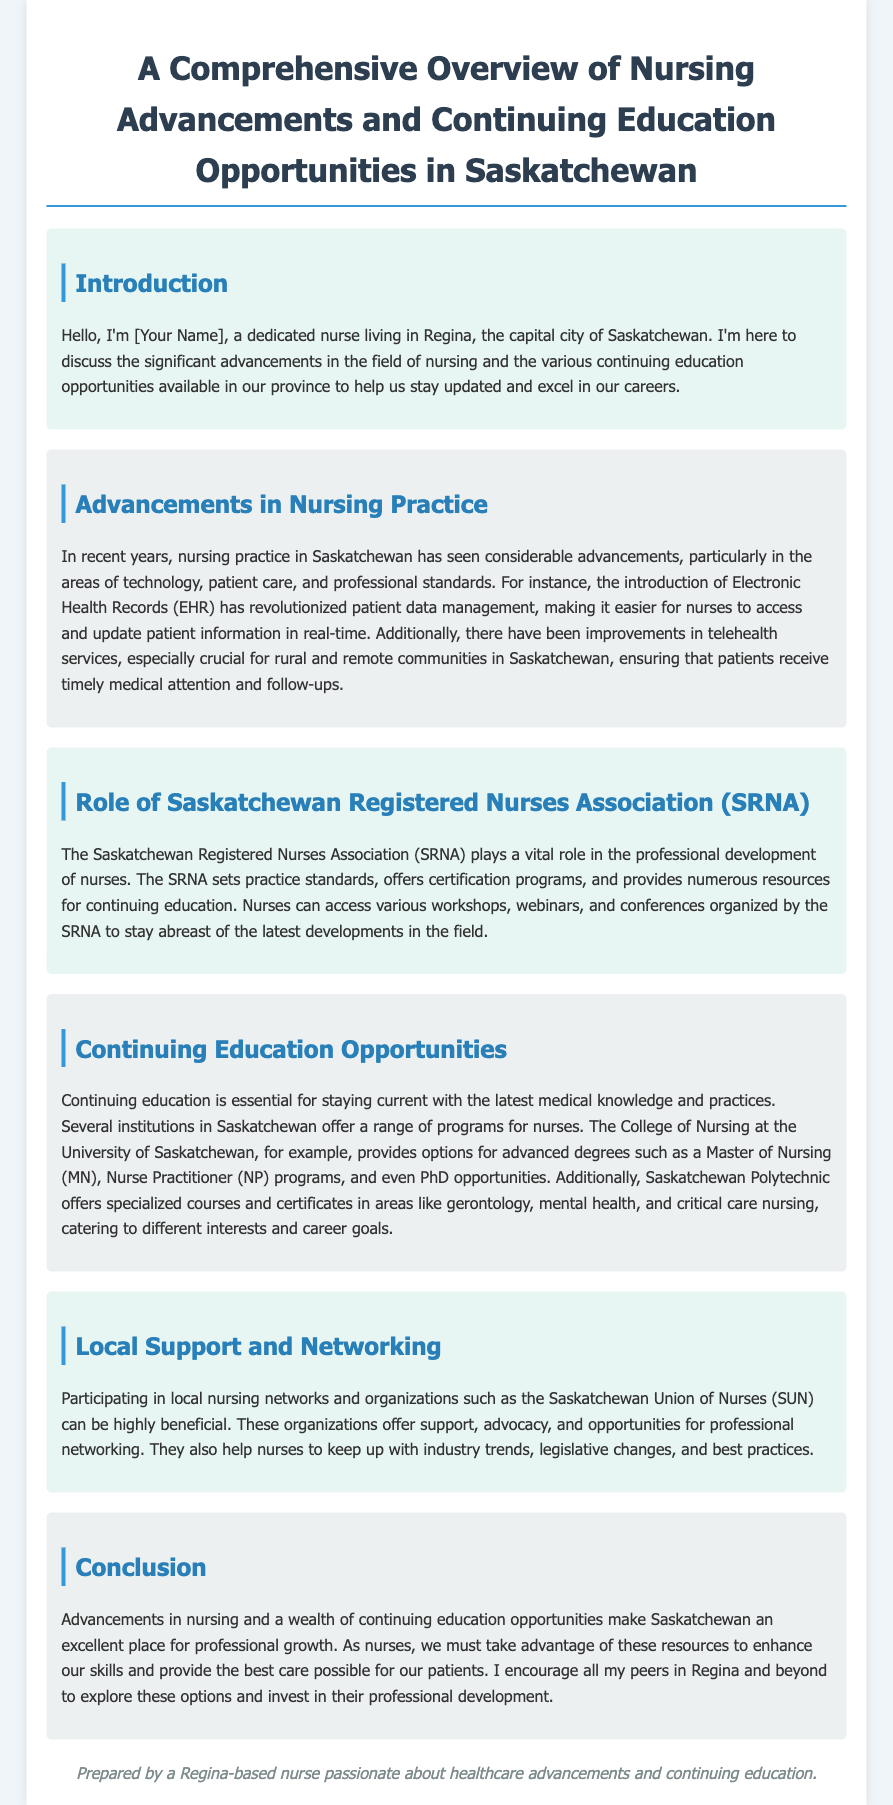What are some advancements in nursing practice in Saskatchewan? The document lists advancements in technology, patient care, and professional standards, emphasizing Electronic Health Records and improvements in telehealth services.
Answer: Technology, patient care, professional standards Who sets practice standards for nurses in Saskatchewan? The Saskatchewan Registered Nurses Association (SRNA) is responsible for setting practice standards and providing resources for continuing education.
Answer: Saskatchewan Registered Nurses Association (SRNA) What type of continuing education programs does the College of Nursing offer? The College of Nursing provides advanced degrees such as a Master of Nursing, Nurse Practitioner programs, and PhD opportunities.
Answer: Master of Nursing, Nurse Practitioner, PhD Which organization offers support and networking opportunities for nurses? The Saskatchewan Union of Nurses (SUN) offers support, advocacy, and networking opportunities for professional development.
Answer: Saskatchewan Union of Nurses (SUN) What essential role does continuing education play for nurses? Continuing education is essential for nurses to stay current with the latest medical knowledge and practices.
Answer: Staying current What is the location of the College of Nursing mentioned in the document? The document states that the College of Nursing is located at the University of Saskatchewan.
Answer: University of Saskatchewan How does telehealth benefit rural communities in Saskatchewan? Telehealth services ensure that patients in rural and remote communities receive timely medical attention and follow-ups.
Answer: Timely medical attention What is the goal of the conclusion in the document? The conclusion encourages nurses to explore continuing education opportunities to enhance their skills and provide the best care possible.
Answer: Enhance skills Who prepared the document? The document states it was prepared by a Regina-based nurse passionate about healthcare advancements and continuing education.
Answer: Regina-based nurse 